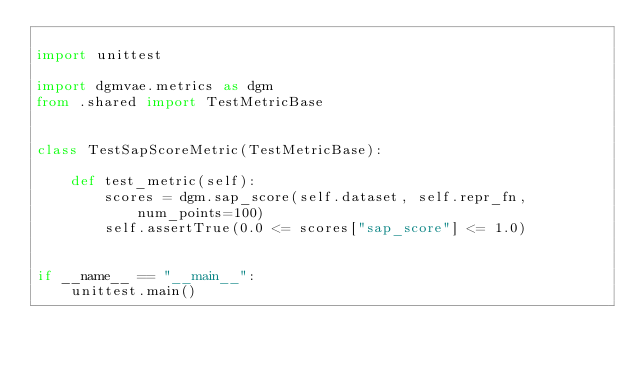Convert code to text. <code><loc_0><loc_0><loc_500><loc_500><_Python_>
import unittest

import dgmvae.metrics as dgm
from .shared import TestMetricBase


class TestSapScoreMetric(TestMetricBase):

    def test_metric(self):
        scores = dgm.sap_score(self.dataset, self.repr_fn, num_points=100)
        self.assertTrue(0.0 <= scores["sap_score"] <= 1.0)


if __name__ == "__main__":
    unittest.main()
</code> 